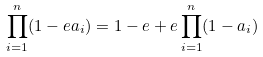Convert formula to latex. <formula><loc_0><loc_0><loc_500><loc_500>\prod _ { i = 1 } ^ { n } ( 1 - e a _ { i } ) = 1 - e + e \prod _ { i = 1 } ^ { n } ( 1 - a _ { i } )</formula> 